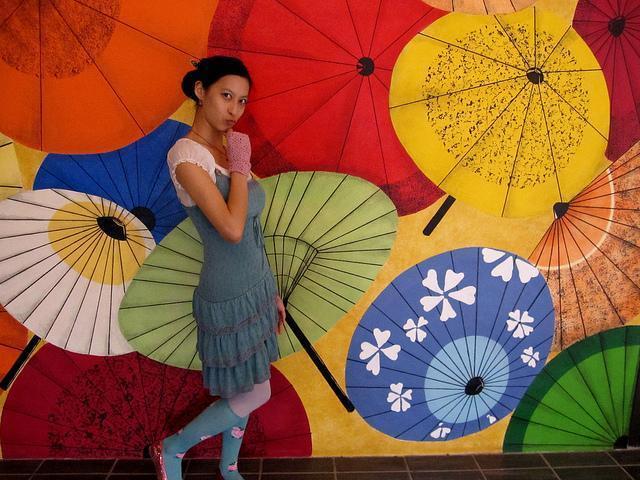How many umbrellas can you see?
Give a very brief answer. 11. 